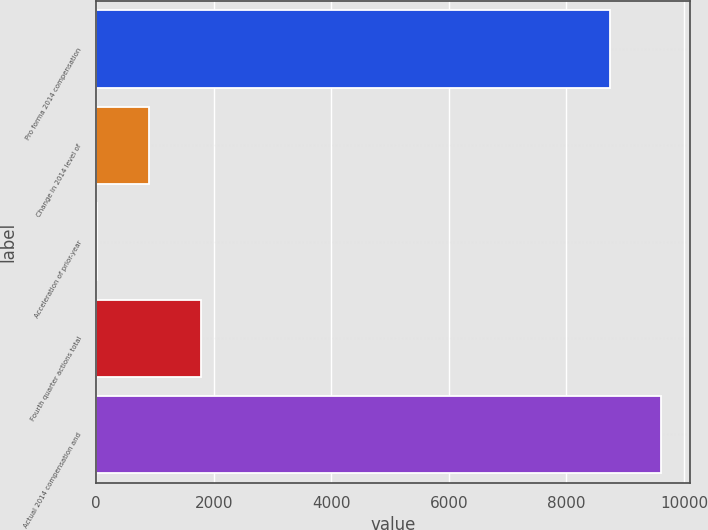<chart> <loc_0><loc_0><loc_500><loc_500><bar_chart><fcel>Pro forma 2014 compensation<fcel>Change in 2014 level of<fcel>Acceleration of prior-year<fcel>Fourth quarter actions total<fcel>Actual 2014 compensation and<nl><fcel>8737<fcel>902.3<fcel>22<fcel>1782.6<fcel>9617.3<nl></chart> 